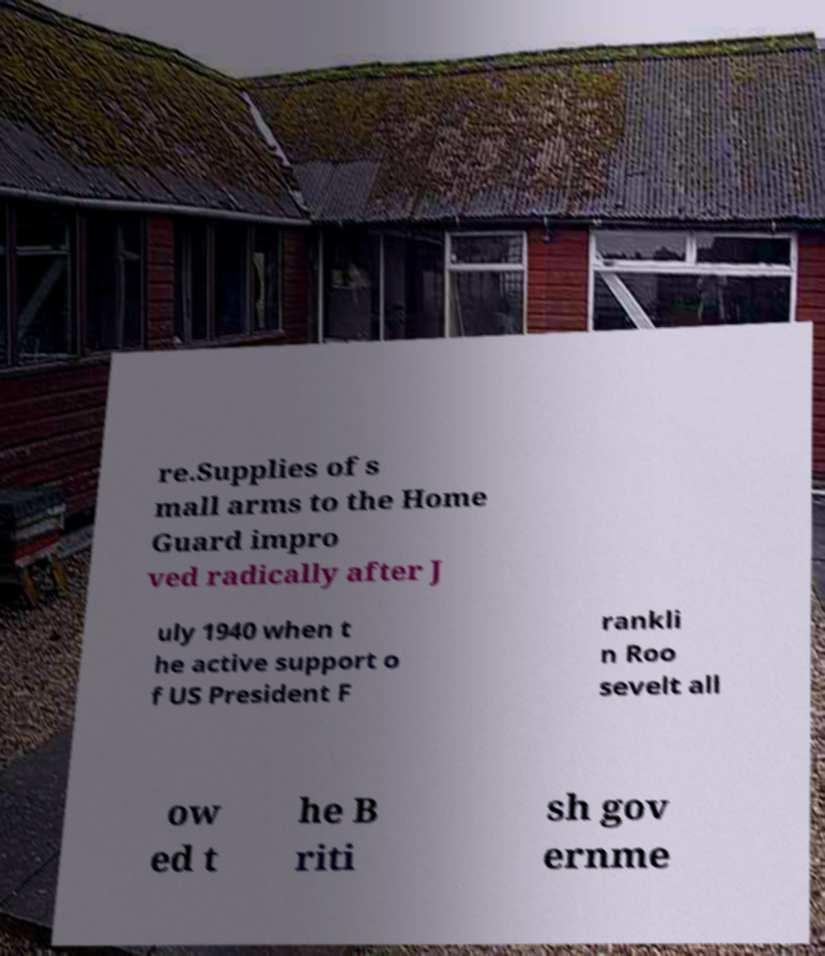What messages or text are displayed in this image? I need them in a readable, typed format. re.Supplies of s mall arms to the Home Guard impro ved radically after J uly 1940 when t he active support o f US President F rankli n Roo sevelt all ow ed t he B riti sh gov ernme 